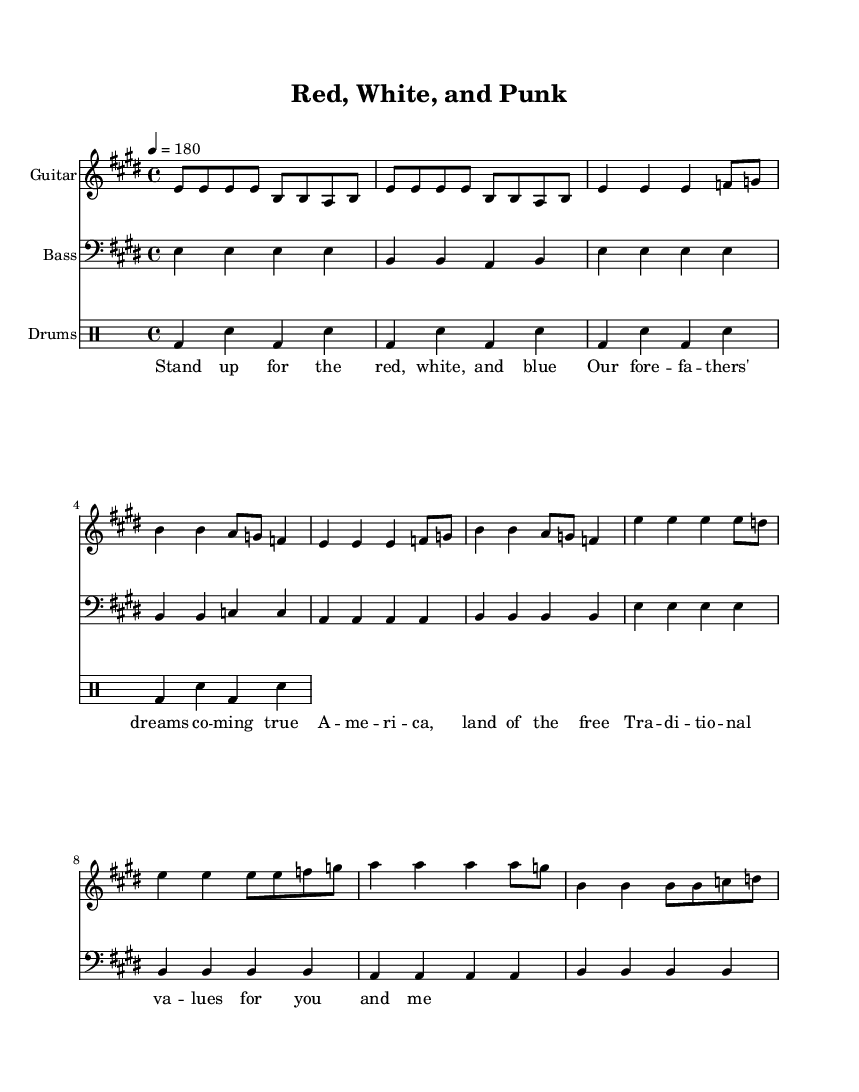What is the key signature of this music? The key signature is E major, which has four sharps (F#, C#, G#, D#). This can be determined by checking the key signature at the beginning of the sheet music.
Answer: E major What is the time signature of this piece? The time signature is 4/4, which indicates that there are four beats in a measure and the quarter note receives one beat. This is observed at the beginning of the music.
Answer: 4/4 What is the tempo marking for the music? The tempo marking is 4 = 180, indicating the quarter note is to be played at 180 beats per minute. This is found next to the tempo directive in the sheet music.
Answer: 180 How many measures are in the verse section? The verse section consists of four measures, as indicated by the grouping of notes in the verse part of the sheet music. Each distinct grouping counts as one measure, and there are four such groupings.
Answer: 4 What instrument plays the lowest notes in this arrangement? The instrument that plays the lowest notes in this arrangement is the bass guitar. This is evident from the clef notation in the bass part, which indicates it is written in bass clef, typically used for lower pitched instruments.
Answer: Bass Which lyrics are associated with the chorus of this song? The lyrics for the chorus are “Stand up for the red, white, and blue." These lyrics are located in the lyrics section directly below the corresponding measures in the music.
Answer: Stand up for the red, white, and blue What kind of drum pattern is used throughout the music? The drum pattern is a basic rock beat, which is characterized by the bass drum and snare drum hitting alternately. This can be identified by examining the drum notation in the drums part.
Answer: Basic rock beat 